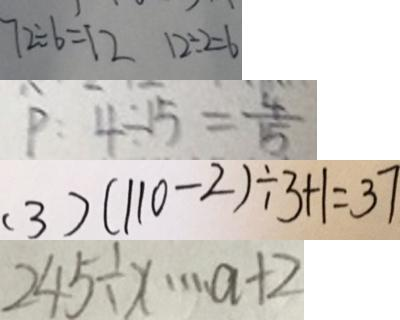<formula> <loc_0><loc_0><loc_500><loc_500>7 2 \div 6 = 1 2 1 2 \div 2 = 6 
 p : 4 \div 1 5 = \frac { 4 } { 1 5 } 
 ( 3 ) ( 1 1 0 - 2 ) \div 3 + 1 = 3 7 
 2 4 5 \div x \cdots a + 2</formula> 